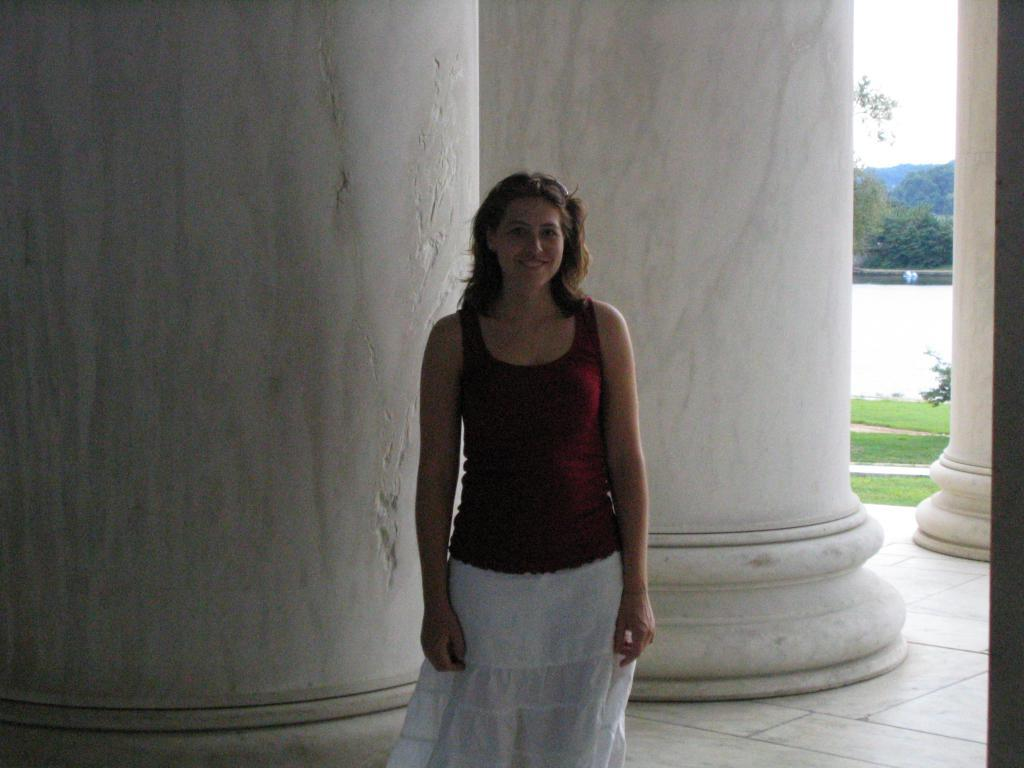What is the main subject of the image? There is a lady standing in the image. What can be seen in the background of the image? There are pillars, trees, and grass in the background of the image. How many geese are sitting on the lady's chin in the image? There are no geese present in the image, and the lady's chin is not visible. What type of system is being used to control the trees in the background? There is no system present in the image to control the trees; they are natural vegetation. 